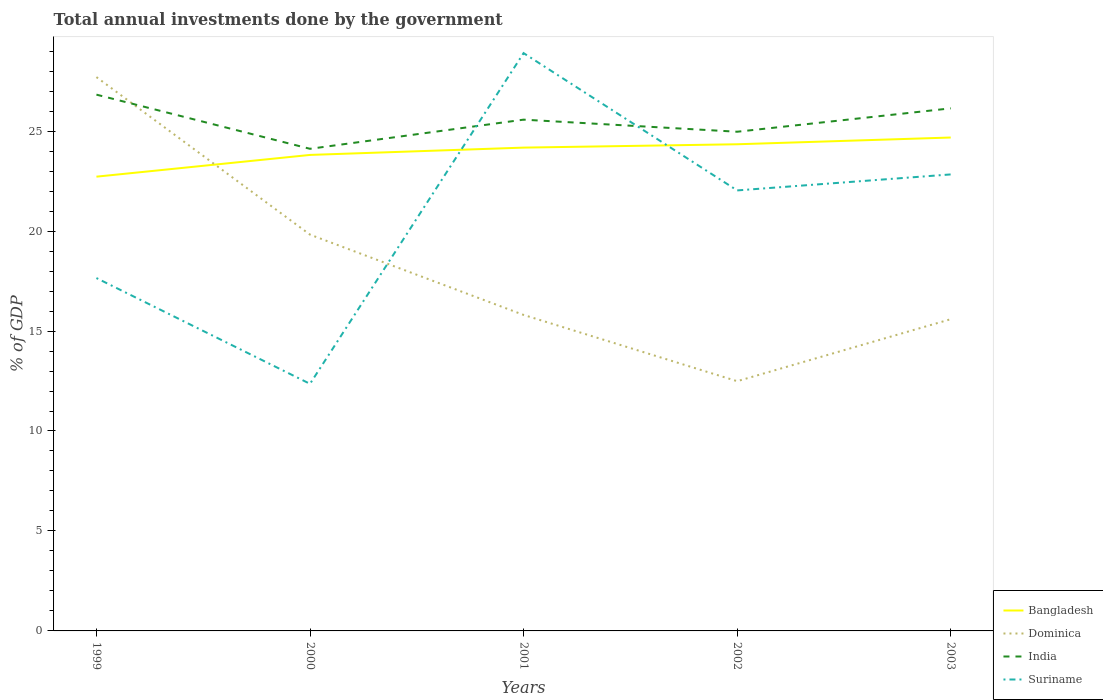How many different coloured lines are there?
Keep it short and to the point. 4. Does the line corresponding to Suriname intersect with the line corresponding to Dominica?
Your answer should be very brief. Yes. Across all years, what is the maximum total annual investments done by the government in Suriname?
Make the answer very short. 12.36. In which year was the total annual investments done by the government in Suriname maximum?
Give a very brief answer. 2000. What is the total total annual investments done by the government in Suriname in the graph?
Make the answer very short. -9.67. What is the difference between the highest and the second highest total annual investments done by the government in Bangladesh?
Give a very brief answer. 1.96. Is the total annual investments done by the government in India strictly greater than the total annual investments done by the government in Bangladesh over the years?
Make the answer very short. No. How many years are there in the graph?
Provide a succinct answer. 5. Does the graph contain grids?
Offer a terse response. No. How many legend labels are there?
Offer a very short reply. 4. What is the title of the graph?
Provide a succinct answer. Total annual investments done by the government. Does "Gambia, The" appear as one of the legend labels in the graph?
Keep it short and to the point. No. What is the label or title of the X-axis?
Offer a terse response. Years. What is the label or title of the Y-axis?
Offer a terse response. % of GDP. What is the % of GDP of Bangladesh in 1999?
Your response must be concise. 22.72. What is the % of GDP in Dominica in 1999?
Make the answer very short. 27.7. What is the % of GDP of India in 1999?
Provide a short and direct response. 26.82. What is the % of GDP in Suriname in 1999?
Keep it short and to the point. 17.65. What is the % of GDP of Bangladesh in 2000?
Keep it short and to the point. 23.81. What is the % of GDP of Dominica in 2000?
Offer a terse response. 19.82. What is the % of GDP of India in 2000?
Keep it short and to the point. 24.11. What is the % of GDP in Suriname in 2000?
Provide a short and direct response. 12.36. What is the % of GDP of Bangladesh in 2001?
Give a very brief answer. 24.17. What is the % of GDP in Dominica in 2001?
Keep it short and to the point. 15.81. What is the % of GDP in India in 2001?
Provide a short and direct response. 25.57. What is the % of GDP in Suriname in 2001?
Ensure brevity in your answer.  28.9. What is the % of GDP of Bangladesh in 2002?
Offer a terse response. 24.34. What is the % of GDP in Dominica in 2002?
Offer a very short reply. 12.49. What is the % of GDP in India in 2002?
Offer a very short reply. 24.97. What is the % of GDP in Suriname in 2002?
Ensure brevity in your answer.  22.03. What is the % of GDP of Bangladesh in 2003?
Provide a short and direct response. 24.68. What is the % of GDP in Dominica in 2003?
Offer a terse response. 15.59. What is the % of GDP of India in 2003?
Provide a succinct answer. 26.14. What is the % of GDP of Suriname in 2003?
Make the answer very short. 22.83. Across all years, what is the maximum % of GDP in Bangladesh?
Offer a very short reply. 24.68. Across all years, what is the maximum % of GDP in Dominica?
Your answer should be very brief. 27.7. Across all years, what is the maximum % of GDP in India?
Your answer should be compact. 26.82. Across all years, what is the maximum % of GDP in Suriname?
Your response must be concise. 28.9. Across all years, what is the minimum % of GDP of Bangladesh?
Your answer should be very brief. 22.72. Across all years, what is the minimum % of GDP in Dominica?
Give a very brief answer. 12.49. Across all years, what is the minimum % of GDP of India?
Provide a short and direct response. 24.11. Across all years, what is the minimum % of GDP in Suriname?
Your answer should be compact. 12.36. What is the total % of GDP in Bangladesh in the graph?
Offer a terse response. 119.72. What is the total % of GDP of Dominica in the graph?
Give a very brief answer. 91.41. What is the total % of GDP in India in the graph?
Offer a terse response. 127.62. What is the total % of GDP of Suriname in the graph?
Your answer should be very brief. 103.78. What is the difference between the % of GDP in Bangladesh in 1999 and that in 2000?
Your answer should be very brief. -1.09. What is the difference between the % of GDP of Dominica in 1999 and that in 2000?
Make the answer very short. 7.88. What is the difference between the % of GDP of India in 1999 and that in 2000?
Provide a short and direct response. 2.71. What is the difference between the % of GDP in Suriname in 1999 and that in 2000?
Your answer should be very brief. 5.29. What is the difference between the % of GDP of Bangladesh in 1999 and that in 2001?
Your answer should be compact. -1.45. What is the difference between the % of GDP of Dominica in 1999 and that in 2001?
Provide a succinct answer. 11.89. What is the difference between the % of GDP of India in 1999 and that in 2001?
Make the answer very short. 1.25. What is the difference between the % of GDP of Suriname in 1999 and that in 2001?
Offer a terse response. -11.25. What is the difference between the % of GDP of Bangladesh in 1999 and that in 2002?
Offer a terse response. -1.62. What is the difference between the % of GDP in Dominica in 1999 and that in 2002?
Your response must be concise. 15.21. What is the difference between the % of GDP in India in 1999 and that in 2002?
Provide a succinct answer. 1.86. What is the difference between the % of GDP in Suriname in 1999 and that in 2002?
Offer a terse response. -4.38. What is the difference between the % of GDP of Bangladesh in 1999 and that in 2003?
Offer a terse response. -1.96. What is the difference between the % of GDP in Dominica in 1999 and that in 2003?
Provide a short and direct response. 12.11. What is the difference between the % of GDP of India in 1999 and that in 2003?
Ensure brevity in your answer.  0.69. What is the difference between the % of GDP in Suriname in 1999 and that in 2003?
Provide a short and direct response. -5.18. What is the difference between the % of GDP of Bangladesh in 2000 and that in 2001?
Offer a very short reply. -0.37. What is the difference between the % of GDP of Dominica in 2000 and that in 2001?
Provide a succinct answer. 4.02. What is the difference between the % of GDP of India in 2000 and that in 2001?
Provide a short and direct response. -1.46. What is the difference between the % of GDP of Suriname in 2000 and that in 2001?
Give a very brief answer. -16.54. What is the difference between the % of GDP in Bangladesh in 2000 and that in 2002?
Ensure brevity in your answer.  -0.53. What is the difference between the % of GDP in Dominica in 2000 and that in 2002?
Make the answer very short. 7.33. What is the difference between the % of GDP of India in 2000 and that in 2002?
Your response must be concise. -0.85. What is the difference between the % of GDP of Suriname in 2000 and that in 2002?
Make the answer very short. -9.67. What is the difference between the % of GDP of Bangladesh in 2000 and that in 2003?
Offer a very short reply. -0.87. What is the difference between the % of GDP in Dominica in 2000 and that in 2003?
Offer a terse response. 4.23. What is the difference between the % of GDP of India in 2000 and that in 2003?
Provide a succinct answer. -2.02. What is the difference between the % of GDP in Suriname in 2000 and that in 2003?
Provide a short and direct response. -10.47. What is the difference between the % of GDP in Bangladesh in 2001 and that in 2002?
Your answer should be compact. -0.17. What is the difference between the % of GDP in Dominica in 2001 and that in 2002?
Provide a succinct answer. 3.31. What is the difference between the % of GDP of India in 2001 and that in 2002?
Provide a short and direct response. 0.6. What is the difference between the % of GDP in Suriname in 2001 and that in 2002?
Keep it short and to the point. 6.87. What is the difference between the % of GDP in Bangladesh in 2001 and that in 2003?
Offer a very short reply. -0.5. What is the difference between the % of GDP of Dominica in 2001 and that in 2003?
Your answer should be very brief. 0.21. What is the difference between the % of GDP in India in 2001 and that in 2003?
Your response must be concise. -0.57. What is the difference between the % of GDP of Suriname in 2001 and that in 2003?
Offer a terse response. 6.07. What is the difference between the % of GDP of Bangladesh in 2002 and that in 2003?
Keep it short and to the point. -0.34. What is the difference between the % of GDP in Dominica in 2002 and that in 2003?
Your response must be concise. -3.1. What is the difference between the % of GDP of India in 2002 and that in 2003?
Offer a very short reply. -1.17. What is the difference between the % of GDP of Suriname in 2002 and that in 2003?
Your answer should be compact. -0.8. What is the difference between the % of GDP of Bangladesh in 1999 and the % of GDP of Dominica in 2000?
Offer a terse response. 2.9. What is the difference between the % of GDP in Bangladesh in 1999 and the % of GDP in India in 2000?
Your response must be concise. -1.39. What is the difference between the % of GDP in Bangladesh in 1999 and the % of GDP in Suriname in 2000?
Give a very brief answer. 10.36. What is the difference between the % of GDP in Dominica in 1999 and the % of GDP in India in 2000?
Your answer should be very brief. 3.59. What is the difference between the % of GDP of Dominica in 1999 and the % of GDP of Suriname in 2000?
Give a very brief answer. 15.34. What is the difference between the % of GDP in India in 1999 and the % of GDP in Suriname in 2000?
Make the answer very short. 14.46. What is the difference between the % of GDP of Bangladesh in 1999 and the % of GDP of Dominica in 2001?
Provide a short and direct response. 6.92. What is the difference between the % of GDP in Bangladesh in 1999 and the % of GDP in India in 2001?
Your answer should be compact. -2.85. What is the difference between the % of GDP in Bangladesh in 1999 and the % of GDP in Suriname in 2001?
Keep it short and to the point. -6.18. What is the difference between the % of GDP in Dominica in 1999 and the % of GDP in India in 2001?
Your response must be concise. 2.13. What is the difference between the % of GDP in Dominica in 1999 and the % of GDP in Suriname in 2001?
Provide a short and direct response. -1.2. What is the difference between the % of GDP of India in 1999 and the % of GDP of Suriname in 2001?
Keep it short and to the point. -2.08. What is the difference between the % of GDP of Bangladesh in 1999 and the % of GDP of Dominica in 2002?
Keep it short and to the point. 10.23. What is the difference between the % of GDP in Bangladesh in 1999 and the % of GDP in India in 2002?
Provide a short and direct response. -2.25. What is the difference between the % of GDP in Bangladesh in 1999 and the % of GDP in Suriname in 2002?
Your answer should be very brief. 0.69. What is the difference between the % of GDP of Dominica in 1999 and the % of GDP of India in 2002?
Offer a terse response. 2.73. What is the difference between the % of GDP in Dominica in 1999 and the % of GDP in Suriname in 2002?
Your response must be concise. 5.67. What is the difference between the % of GDP of India in 1999 and the % of GDP of Suriname in 2002?
Give a very brief answer. 4.79. What is the difference between the % of GDP of Bangladesh in 1999 and the % of GDP of Dominica in 2003?
Provide a succinct answer. 7.13. What is the difference between the % of GDP in Bangladesh in 1999 and the % of GDP in India in 2003?
Offer a terse response. -3.42. What is the difference between the % of GDP of Bangladesh in 1999 and the % of GDP of Suriname in 2003?
Offer a terse response. -0.11. What is the difference between the % of GDP of Dominica in 1999 and the % of GDP of India in 2003?
Offer a terse response. 1.56. What is the difference between the % of GDP in Dominica in 1999 and the % of GDP in Suriname in 2003?
Make the answer very short. 4.87. What is the difference between the % of GDP of India in 1999 and the % of GDP of Suriname in 2003?
Your response must be concise. 3.99. What is the difference between the % of GDP of Bangladesh in 2000 and the % of GDP of Dominica in 2001?
Provide a succinct answer. 8. What is the difference between the % of GDP of Bangladesh in 2000 and the % of GDP of India in 2001?
Provide a succinct answer. -1.76. What is the difference between the % of GDP in Bangladesh in 2000 and the % of GDP in Suriname in 2001?
Keep it short and to the point. -5.09. What is the difference between the % of GDP in Dominica in 2000 and the % of GDP in India in 2001?
Make the answer very short. -5.75. What is the difference between the % of GDP of Dominica in 2000 and the % of GDP of Suriname in 2001?
Your answer should be very brief. -9.08. What is the difference between the % of GDP in India in 2000 and the % of GDP in Suriname in 2001?
Your answer should be compact. -4.79. What is the difference between the % of GDP of Bangladesh in 2000 and the % of GDP of Dominica in 2002?
Make the answer very short. 11.32. What is the difference between the % of GDP of Bangladesh in 2000 and the % of GDP of India in 2002?
Keep it short and to the point. -1.16. What is the difference between the % of GDP of Bangladesh in 2000 and the % of GDP of Suriname in 2002?
Your response must be concise. 1.78. What is the difference between the % of GDP in Dominica in 2000 and the % of GDP in India in 2002?
Offer a terse response. -5.15. What is the difference between the % of GDP of Dominica in 2000 and the % of GDP of Suriname in 2002?
Your answer should be very brief. -2.21. What is the difference between the % of GDP of India in 2000 and the % of GDP of Suriname in 2002?
Your response must be concise. 2.08. What is the difference between the % of GDP of Bangladesh in 2000 and the % of GDP of Dominica in 2003?
Your answer should be compact. 8.22. What is the difference between the % of GDP in Bangladesh in 2000 and the % of GDP in India in 2003?
Keep it short and to the point. -2.33. What is the difference between the % of GDP in Bangladesh in 2000 and the % of GDP in Suriname in 2003?
Offer a very short reply. 0.98. What is the difference between the % of GDP in Dominica in 2000 and the % of GDP in India in 2003?
Provide a short and direct response. -6.32. What is the difference between the % of GDP in Dominica in 2000 and the % of GDP in Suriname in 2003?
Your answer should be compact. -3.01. What is the difference between the % of GDP of India in 2000 and the % of GDP of Suriname in 2003?
Your response must be concise. 1.28. What is the difference between the % of GDP in Bangladesh in 2001 and the % of GDP in Dominica in 2002?
Provide a succinct answer. 11.68. What is the difference between the % of GDP of Bangladesh in 2001 and the % of GDP of India in 2002?
Your response must be concise. -0.79. What is the difference between the % of GDP of Bangladesh in 2001 and the % of GDP of Suriname in 2002?
Offer a very short reply. 2.14. What is the difference between the % of GDP of Dominica in 2001 and the % of GDP of India in 2002?
Ensure brevity in your answer.  -9.16. What is the difference between the % of GDP of Dominica in 2001 and the % of GDP of Suriname in 2002?
Ensure brevity in your answer.  -6.23. What is the difference between the % of GDP of India in 2001 and the % of GDP of Suriname in 2002?
Provide a short and direct response. 3.54. What is the difference between the % of GDP in Bangladesh in 2001 and the % of GDP in Dominica in 2003?
Offer a very short reply. 8.58. What is the difference between the % of GDP in Bangladesh in 2001 and the % of GDP in India in 2003?
Provide a succinct answer. -1.96. What is the difference between the % of GDP of Bangladesh in 2001 and the % of GDP of Suriname in 2003?
Offer a terse response. 1.34. What is the difference between the % of GDP of Dominica in 2001 and the % of GDP of India in 2003?
Offer a very short reply. -10.33. What is the difference between the % of GDP in Dominica in 2001 and the % of GDP in Suriname in 2003?
Offer a terse response. -7.03. What is the difference between the % of GDP of India in 2001 and the % of GDP of Suriname in 2003?
Offer a very short reply. 2.74. What is the difference between the % of GDP in Bangladesh in 2002 and the % of GDP in Dominica in 2003?
Provide a short and direct response. 8.75. What is the difference between the % of GDP in Bangladesh in 2002 and the % of GDP in India in 2003?
Keep it short and to the point. -1.8. What is the difference between the % of GDP in Bangladesh in 2002 and the % of GDP in Suriname in 2003?
Provide a short and direct response. 1.51. What is the difference between the % of GDP in Dominica in 2002 and the % of GDP in India in 2003?
Your answer should be compact. -13.65. What is the difference between the % of GDP of Dominica in 2002 and the % of GDP of Suriname in 2003?
Keep it short and to the point. -10.34. What is the difference between the % of GDP in India in 2002 and the % of GDP in Suriname in 2003?
Provide a succinct answer. 2.13. What is the average % of GDP of Bangladesh per year?
Ensure brevity in your answer.  23.95. What is the average % of GDP of Dominica per year?
Offer a very short reply. 18.28. What is the average % of GDP in India per year?
Offer a very short reply. 25.52. What is the average % of GDP in Suriname per year?
Offer a terse response. 20.76. In the year 1999, what is the difference between the % of GDP of Bangladesh and % of GDP of Dominica?
Provide a short and direct response. -4.98. In the year 1999, what is the difference between the % of GDP of Bangladesh and % of GDP of India?
Your answer should be very brief. -4.1. In the year 1999, what is the difference between the % of GDP in Bangladesh and % of GDP in Suriname?
Provide a succinct answer. 5.07. In the year 1999, what is the difference between the % of GDP of Dominica and % of GDP of India?
Give a very brief answer. 0.88. In the year 1999, what is the difference between the % of GDP of Dominica and % of GDP of Suriname?
Provide a short and direct response. 10.05. In the year 1999, what is the difference between the % of GDP in India and % of GDP in Suriname?
Give a very brief answer. 9.17. In the year 2000, what is the difference between the % of GDP in Bangladesh and % of GDP in Dominica?
Give a very brief answer. 3.99. In the year 2000, what is the difference between the % of GDP in Bangladesh and % of GDP in India?
Offer a very short reply. -0.31. In the year 2000, what is the difference between the % of GDP in Bangladesh and % of GDP in Suriname?
Make the answer very short. 11.45. In the year 2000, what is the difference between the % of GDP in Dominica and % of GDP in India?
Your answer should be compact. -4.29. In the year 2000, what is the difference between the % of GDP of Dominica and % of GDP of Suriname?
Keep it short and to the point. 7.46. In the year 2000, what is the difference between the % of GDP of India and % of GDP of Suriname?
Offer a terse response. 11.76. In the year 2001, what is the difference between the % of GDP in Bangladesh and % of GDP in Dominica?
Your answer should be compact. 8.37. In the year 2001, what is the difference between the % of GDP of Bangladesh and % of GDP of India?
Keep it short and to the point. -1.4. In the year 2001, what is the difference between the % of GDP in Bangladesh and % of GDP in Suriname?
Ensure brevity in your answer.  -4.73. In the year 2001, what is the difference between the % of GDP of Dominica and % of GDP of India?
Offer a very short reply. -9.77. In the year 2001, what is the difference between the % of GDP of Dominica and % of GDP of Suriname?
Provide a short and direct response. -13.1. In the year 2001, what is the difference between the % of GDP in India and % of GDP in Suriname?
Provide a short and direct response. -3.33. In the year 2002, what is the difference between the % of GDP of Bangladesh and % of GDP of Dominica?
Your answer should be very brief. 11.85. In the year 2002, what is the difference between the % of GDP of Bangladesh and % of GDP of India?
Give a very brief answer. -0.63. In the year 2002, what is the difference between the % of GDP in Bangladesh and % of GDP in Suriname?
Give a very brief answer. 2.31. In the year 2002, what is the difference between the % of GDP of Dominica and % of GDP of India?
Your answer should be compact. -12.48. In the year 2002, what is the difference between the % of GDP in Dominica and % of GDP in Suriname?
Ensure brevity in your answer.  -9.54. In the year 2002, what is the difference between the % of GDP in India and % of GDP in Suriname?
Offer a very short reply. 2.94. In the year 2003, what is the difference between the % of GDP in Bangladesh and % of GDP in Dominica?
Your answer should be compact. 9.09. In the year 2003, what is the difference between the % of GDP of Bangladesh and % of GDP of India?
Offer a terse response. -1.46. In the year 2003, what is the difference between the % of GDP of Bangladesh and % of GDP of Suriname?
Your response must be concise. 1.85. In the year 2003, what is the difference between the % of GDP in Dominica and % of GDP in India?
Make the answer very short. -10.55. In the year 2003, what is the difference between the % of GDP of Dominica and % of GDP of Suriname?
Provide a succinct answer. -7.24. In the year 2003, what is the difference between the % of GDP of India and % of GDP of Suriname?
Provide a succinct answer. 3.3. What is the ratio of the % of GDP in Bangladesh in 1999 to that in 2000?
Give a very brief answer. 0.95. What is the ratio of the % of GDP in Dominica in 1999 to that in 2000?
Keep it short and to the point. 1.4. What is the ratio of the % of GDP in India in 1999 to that in 2000?
Give a very brief answer. 1.11. What is the ratio of the % of GDP in Suriname in 1999 to that in 2000?
Make the answer very short. 1.43. What is the ratio of the % of GDP in Bangladesh in 1999 to that in 2001?
Make the answer very short. 0.94. What is the ratio of the % of GDP of Dominica in 1999 to that in 2001?
Ensure brevity in your answer.  1.75. What is the ratio of the % of GDP in India in 1999 to that in 2001?
Your answer should be compact. 1.05. What is the ratio of the % of GDP in Suriname in 1999 to that in 2001?
Your answer should be compact. 0.61. What is the ratio of the % of GDP in Bangladesh in 1999 to that in 2002?
Give a very brief answer. 0.93. What is the ratio of the % of GDP in Dominica in 1999 to that in 2002?
Provide a succinct answer. 2.22. What is the ratio of the % of GDP in India in 1999 to that in 2002?
Your answer should be compact. 1.07. What is the ratio of the % of GDP of Suriname in 1999 to that in 2002?
Offer a very short reply. 0.8. What is the ratio of the % of GDP in Bangladesh in 1999 to that in 2003?
Your answer should be compact. 0.92. What is the ratio of the % of GDP in Dominica in 1999 to that in 2003?
Provide a short and direct response. 1.78. What is the ratio of the % of GDP in India in 1999 to that in 2003?
Keep it short and to the point. 1.03. What is the ratio of the % of GDP of Suriname in 1999 to that in 2003?
Your answer should be compact. 0.77. What is the ratio of the % of GDP in Bangladesh in 2000 to that in 2001?
Provide a short and direct response. 0.98. What is the ratio of the % of GDP in Dominica in 2000 to that in 2001?
Your response must be concise. 1.25. What is the ratio of the % of GDP of India in 2000 to that in 2001?
Offer a terse response. 0.94. What is the ratio of the % of GDP of Suriname in 2000 to that in 2001?
Your answer should be compact. 0.43. What is the ratio of the % of GDP in Bangladesh in 2000 to that in 2002?
Offer a terse response. 0.98. What is the ratio of the % of GDP in Dominica in 2000 to that in 2002?
Offer a very short reply. 1.59. What is the ratio of the % of GDP in India in 2000 to that in 2002?
Provide a short and direct response. 0.97. What is the ratio of the % of GDP of Suriname in 2000 to that in 2002?
Make the answer very short. 0.56. What is the ratio of the % of GDP of Bangladesh in 2000 to that in 2003?
Ensure brevity in your answer.  0.96. What is the ratio of the % of GDP of Dominica in 2000 to that in 2003?
Offer a very short reply. 1.27. What is the ratio of the % of GDP of India in 2000 to that in 2003?
Provide a short and direct response. 0.92. What is the ratio of the % of GDP in Suriname in 2000 to that in 2003?
Ensure brevity in your answer.  0.54. What is the ratio of the % of GDP in Dominica in 2001 to that in 2002?
Your answer should be very brief. 1.27. What is the ratio of the % of GDP in India in 2001 to that in 2002?
Offer a terse response. 1.02. What is the ratio of the % of GDP of Suriname in 2001 to that in 2002?
Offer a terse response. 1.31. What is the ratio of the % of GDP in Bangladesh in 2001 to that in 2003?
Your answer should be compact. 0.98. What is the ratio of the % of GDP of Dominica in 2001 to that in 2003?
Ensure brevity in your answer.  1.01. What is the ratio of the % of GDP in India in 2001 to that in 2003?
Make the answer very short. 0.98. What is the ratio of the % of GDP of Suriname in 2001 to that in 2003?
Your answer should be very brief. 1.27. What is the ratio of the % of GDP of Bangladesh in 2002 to that in 2003?
Your answer should be very brief. 0.99. What is the ratio of the % of GDP of Dominica in 2002 to that in 2003?
Offer a very short reply. 0.8. What is the ratio of the % of GDP of India in 2002 to that in 2003?
Your answer should be compact. 0.96. What is the difference between the highest and the second highest % of GDP in Bangladesh?
Keep it short and to the point. 0.34. What is the difference between the highest and the second highest % of GDP in Dominica?
Provide a succinct answer. 7.88. What is the difference between the highest and the second highest % of GDP in India?
Offer a terse response. 0.69. What is the difference between the highest and the second highest % of GDP of Suriname?
Offer a very short reply. 6.07. What is the difference between the highest and the lowest % of GDP in Bangladesh?
Your answer should be very brief. 1.96. What is the difference between the highest and the lowest % of GDP of Dominica?
Offer a terse response. 15.21. What is the difference between the highest and the lowest % of GDP of India?
Your response must be concise. 2.71. What is the difference between the highest and the lowest % of GDP of Suriname?
Provide a succinct answer. 16.54. 